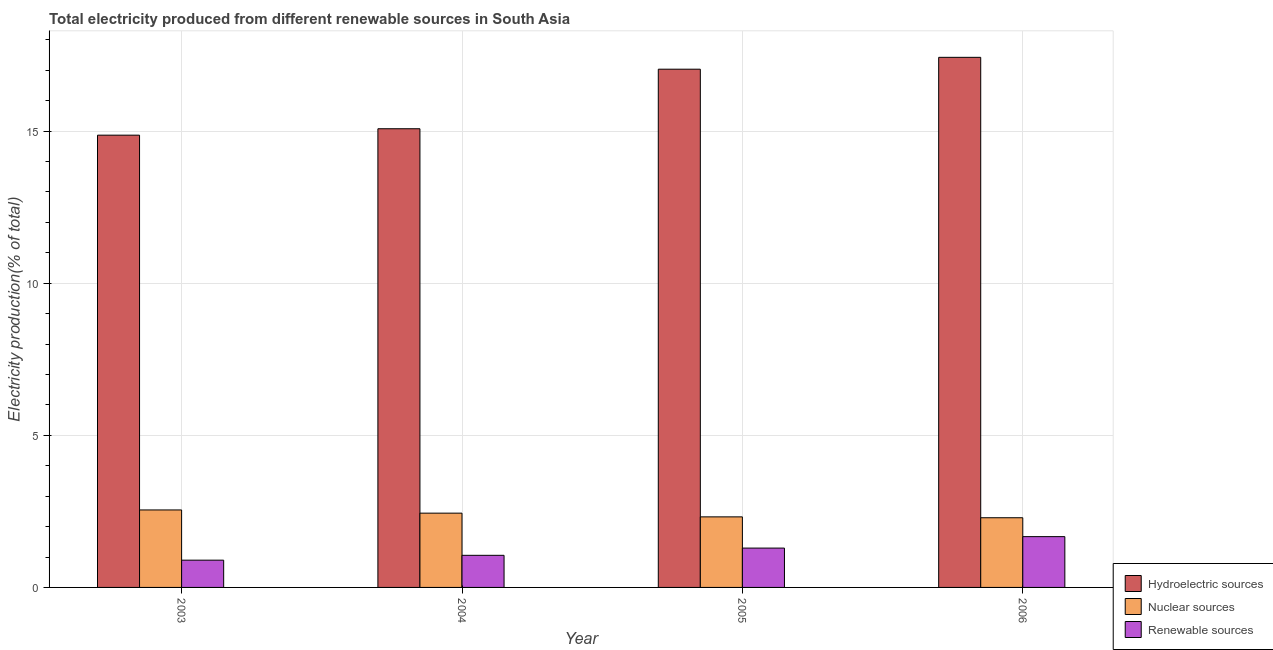How many groups of bars are there?
Keep it short and to the point. 4. Are the number of bars per tick equal to the number of legend labels?
Your answer should be compact. Yes. How many bars are there on the 4th tick from the left?
Your answer should be compact. 3. In how many cases, is the number of bars for a given year not equal to the number of legend labels?
Give a very brief answer. 0. What is the percentage of electricity produced by nuclear sources in 2006?
Your answer should be very brief. 2.29. Across all years, what is the maximum percentage of electricity produced by nuclear sources?
Ensure brevity in your answer.  2.55. Across all years, what is the minimum percentage of electricity produced by nuclear sources?
Offer a very short reply. 2.29. In which year was the percentage of electricity produced by renewable sources maximum?
Offer a terse response. 2006. In which year was the percentage of electricity produced by hydroelectric sources minimum?
Your answer should be compact. 2003. What is the total percentage of electricity produced by nuclear sources in the graph?
Ensure brevity in your answer.  9.6. What is the difference between the percentage of electricity produced by nuclear sources in 2005 and that in 2006?
Offer a very short reply. 0.03. What is the difference between the percentage of electricity produced by hydroelectric sources in 2005 and the percentage of electricity produced by nuclear sources in 2004?
Give a very brief answer. 1.96. What is the average percentage of electricity produced by nuclear sources per year?
Provide a succinct answer. 2.4. In the year 2006, what is the difference between the percentage of electricity produced by hydroelectric sources and percentage of electricity produced by nuclear sources?
Ensure brevity in your answer.  0. What is the ratio of the percentage of electricity produced by renewable sources in 2005 to that in 2006?
Offer a terse response. 0.77. Is the difference between the percentage of electricity produced by hydroelectric sources in 2005 and 2006 greater than the difference between the percentage of electricity produced by renewable sources in 2005 and 2006?
Your answer should be very brief. No. What is the difference between the highest and the second highest percentage of electricity produced by nuclear sources?
Make the answer very short. 0.11. What is the difference between the highest and the lowest percentage of electricity produced by hydroelectric sources?
Offer a terse response. 2.56. In how many years, is the percentage of electricity produced by nuclear sources greater than the average percentage of electricity produced by nuclear sources taken over all years?
Your answer should be compact. 2. Is the sum of the percentage of electricity produced by hydroelectric sources in 2004 and 2006 greater than the maximum percentage of electricity produced by nuclear sources across all years?
Keep it short and to the point. Yes. What does the 2nd bar from the left in 2006 represents?
Offer a very short reply. Nuclear sources. What does the 1st bar from the right in 2004 represents?
Provide a succinct answer. Renewable sources. Is it the case that in every year, the sum of the percentage of electricity produced by hydroelectric sources and percentage of electricity produced by nuclear sources is greater than the percentage of electricity produced by renewable sources?
Provide a short and direct response. Yes. How many bars are there?
Offer a very short reply. 12. What is the difference between two consecutive major ticks on the Y-axis?
Keep it short and to the point. 5. Are the values on the major ticks of Y-axis written in scientific E-notation?
Provide a succinct answer. No. Does the graph contain any zero values?
Your answer should be compact. No. Where does the legend appear in the graph?
Provide a short and direct response. Bottom right. How many legend labels are there?
Provide a short and direct response. 3. How are the legend labels stacked?
Your answer should be very brief. Vertical. What is the title of the graph?
Your response must be concise. Total electricity produced from different renewable sources in South Asia. Does "Taxes on international trade" appear as one of the legend labels in the graph?
Offer a very short reply. No. What is the label or title of the X-axis?
Make the answer very short. Year. What is the Electricity production(% of total) in Hydroelectric sources in 2003?
Make the answer very short. 14.87. What is the Electricity production(% of total) of Nuclear sources in 2003?
Your response must be concise. 2.55. What is the Electricity production(% of total) in Renewable sources in 2003?
Offer a terse response. 0.9. What is the Electricity production(% of total) of Hydroelectric sources in 2004?
Your answer should be compact. 15.08. What is the Electricity production(% of total) of Nuclear sources in 2004?
Make the answer very short. 2.44. What is the Electricity production(% of total) of Renewable sources in 2004?
Give a very brief answer. 1.06. What is the Electricity production(% of total) of Hydroelectric sources in 2005?
Offer a terse response. 17.04. What is the Electricity production(% of total) in Nuclear sources in 2005?
Your answer should be very brief. 2.32. What is the Electricity production(% of total) of Renewable sources in 2005?
Offer a terse response. 1.29. What is the Electricity production(% of total) in Hydroelectric sources in 2006?
Provide a succinct answer. 17.43. What is the Electricity production(% of total) of Nuclear sources in 2006?
Offer a terse response. 2.29. What is the Electricity production(% of total) of Renewable sources in 2006?
Offer a very short reply. 1.67. Across all years, what is the maximum Electricity production(% of total) of Hydroelectric sources?
Your answer should be compact. 17.43. Across all years, what is the maximum Electricity production(% of total) of Nuclear sources?
Ensure brevity in your answer.  2.55. Across all years, what is the maximum Electricity production(% of total) of Renewable sources?
Your response must be concise. 1.67. Across all years, what is the minimum Electricity production(% of total) in Hydroelectric sources?
Your answer should be compact. 14.87. Across all years, what is the minimum Electricity production(% of total) of Nuclear sources?
Offer a very short reply. 2.29. Across all years, what is the minimum Electricity production(% of total) in Renewable sources?
Your response must be concise. 0.9. What is the total Electricity production(% of total) in Hydroelectric sources in the graph?
Offer a very short reply. 64.41. What is the total Electricity production(% of total) of Nuclear sources in the graph?
Make the answer very short. 9.6. What is the total Electricity production(% of total) of Renewable sources in the graph?
Your response must be concise. 4.91. What is the difference between the Electricity production(% of total) of Hydroelectric sources in 2003 and that in 2004?
Your answer should be very brief. -0.21. What is the difference between the Electricity production(% of total) of Nuclear sources in 2003 and that in 2004?
Your response must be concise. 0.11. What is the difference between the Electricity production(% of total) of Renewable sources in 2003 and that in 2004?
Your response must be concise. -0.16. What is the difference between the Electricity production(% of total) of Hydroelectric sources in 2003 and that in 2005?
Your response must be concise. -2.17. What is the difference between the Electricity production(% of total) in Nuclear sources in 2003 and that in 2005?
Provide a short and direct response. 0.23. What is the difference between the Electricity production(% of total) of Renewable sources in 2003 and that in 2005?
Your answer should be very brief. -0.4. What is the difference between the Electricity production(% of total) of Hydroelectric sources in 2003 and that in 2006?
Your answer should be very brief. -2.56. What is the difference between the Electricity production(% of total) of Nuclear sources in 2003 and that in 2006?
Provide a succinct answer. 0.26. What is the difference between the Electricity production(% of total) of Renewable sources in 2003 and that in 2006?
Provide a short and direct response. -0.77. What is the difference between the Electricity production(% of total) in Hydroelectric sources in 2004 and that in 2005?
Offer a terse response. -1.96. What is the difference between the Electricity production(% of total) of Nuclear sources in 2004 and that in 2005?
Keep it short and to the point. 0.12. What is the difference between the Electricity production(% of total) of Renewable sources in 2004 and that in 2005?
Your response must be concise. -0.24. What is the difference between the Electricity production(% of total) in Hydroelectric sources in 2004 and that in 2006?
Provide a short and direct response. -2.35. What is the difference between the Electricity production(% of total) of Nuclear sources in 2004 and that in 2006?
Give a very brief answer. 0.15. What is the difference between the Electricity production(% of total) in Renewable sources in 2004 and that in 2006?
Ensure brevity in your answer.  -0.61. What is the difference between the Electricity production(% of total) in Hydroelectric sources in 2005 and that in 2006?
Ensure brevity in your answer.  -0.39. What is the difference between the Electricity production(% of total) of Nuclear sources in 2005 and that in 2006?
Ensure brevity in your answer.  0.03. What is the difference between the Electricity production(% of total) in Renewable sources in 2005 and that in 2006?
Offer a terse response. -0.38. What is the difference between the Electricity production(% of total) of Hydroelectric sources in 2003 and the Electricity production(% of total) of Nuclear sources in 2004?
Ensure brevity in your answer.  12.42. What is the difference between the Electricity production(% of total) of Hydroelectric sources in 2003 and the Electricity production(% of total) of Renewable sources in 2004?
Ensure brevity in your answer.  13.81. What is the difference between the Electricity production(% of total) of Nuclear sources in 2003 and the Electricity production(% of total) of Renewable sources in 2004?
Your response must be concise. 1.49. What is the difference between the Electricity production(% of total) of Hydroelectric sources in 2003 and the Electricity production(% of total) of Nuclear sources in 2005?
Make the answer very short. 12.55. What is the difference between the Electricity production(% of total) in Hydroelectric sources in 2003 and the Electricity production(% of total) in Renewable sources in 2005?
Offer a very short reply. 13.57. What is the difference between the Electricity production(% of total) of Nuclear sources in 2003 and the Electricity production(% of total) of Renewable sources in 2005?
Keep it short and to the point. 1.25. What is the difference between the Electricity production(% of total) of Hydroelectric sources in 2003 and the Electricity production(% of total) of Nuclear sources in 2006?
Provide a succinct answer. 12.58. What is the difference between the Electricity production(% of total) in Hydroelectric sources in 2003 and the Electricity production(% of total) in Renewable sources in 2006?
Give a very brief answer. 13.2. What is the difference between the Electricity production(% of total) in Nuclear sources in 2003 and the Electricity production(% of total) in Renewable sources in 2006?
Your answer should be very brief. 0.88. What is the difference between the Electricity production(% of total) of Hydroelectric sources in 2004 and the Electricity production(% of total) of Nuclear sources in 2005?
Make the answer very short. 12.76. What is the difference between the Electricity production(% of total) in Hydroelectric sources in 2004 and the Electricity production(% of total) in Renewable sources in 2005?
Offer a very short reply. 13.78. What is the difference between the Electricity production(% of total) in Nuclear sources in 2004 and the Electricity production(% of total) in Renewable sources in 2005?
Your response must be concise. 1.15. What is the difference between the Electricity production(% of total) of Hydroelectric sources in 2004 and the Electricity production(% of total) of Nuclear sources in 2006?
Offer a terse response. 12.79. What is the difference between the Electricity production(% of total) in Hydroelectric sources in 2004 and the Electricity production(% of total) in Renewable sources in 2006?
Make the answer very short. 13.41. What is the difference between the Electricity production(% of total) of Nuclear sources in 2004 and the Electricity production(% of total) of Renewable sources in 2006?
Keep it short and to the point. 0.77. What is the difference between the Electricity production(% of total) in Hydroelectric sources in 2005 and the Electricity production(% of total) in Nuclear sources in 2006?
Offer a terse response. 14.74. What is the difference between the Electricity production(% of total) in Hydroelectric sources in 2005 and the Electricity production(% of total) in Renewable sources in 2006?
Ensure brevity in your answer.  15.37. What is the difference between the Electricity production(% of total) of Nuclear sources in 2005 and the Electricity production(% of total) of Renewable sources in 2006?
Your response must be concise. 0.65. What is the average Electricity production(% of total) of Hydroelectric sources per year?
Ensure brevity in your answer.  16.1. What is the average Electricity production(% of total) in Nuclear sources per year?
Your answer should be very brief. 2.4. What is the average Electricity production(% of total) in Renewable sources per year?
Give a very brief answer. 1.23. In the year 2003, what is the difference between the Electricity production(% of total) in Hydroelectric sources and Electricity production(% of total) in Nuclear sources?
Your answer should be compact. 12.32. In the year 2003, what is the difference between the Electricity production(% of total) in Hydroelectric sources and Electricity production(% of total) in Renewable sources?
Make the answer very short. 13.97. In the year 2003, what is the difference between the Electricity production(% of total) in Nuclear sources and Electricity production(% of total) in Renewable sources?
Keep it short and to the point. 1.65. In the year 2004, what is the difference between the Electricity production(% of total) of Hydroelectric sources and Electricity production(% of total) of Nuclear sources?
Provide a short and direct response. 12.64. In the year 2004, what is the difference between the Electricity production(% of total) of Hydroelectric sources and Electricity production(% of total) of Renewable sources?
Keep it short and to the point. 14.02. In the year 2004, what is the difference between the Electricity production(% of total) in Nuclear sources and Electricity production(% of total) in Renewable sources?
Make the answer very short. 1.39. In the year 2005, what is the difference between the Electricity production(% of total) of Hydroelectric sources and Electricity production(% of total) of Nuclear sources?
Keep it short and to the point. 14.72. In the year 2005, what is the difference between the Electricity production(% of total) of Hydroelectric sources and Electricity production(% of total) of Renewable sources?
Provide a succinct answer. 15.74. In the year 2005, what is the difference between the Electricity production(% of total) of Nuclear sources and Electricity production(% of total) of Renewable sources?
Make the answer very short. 1.03. In the year 2006, what is the difference between the Electricity production(% of total) of Hydroelectric sources and Electricity production(% of total) of Nuclear sources?
Offer a very short reply. 15.13. In the year 2006, what is the difference between the Electricity production(% of total) of Hydroelectric sources and Electricity production(% of total) of Renewable sources?
Give a very brief answer. 15.76. In the year 2006, what is the difference between the Electricity production(% of total) in Nuclear sources and Electricity production(% of total) in Renewable sources?
Offer a very short reply. 0.62. What is the ratio of the Electricity production(% of total) of Hydroelectric sources in 2003 to that in 2004?
Provide a short and direct response. 0.99. What is the ratio of the Electricity production(% of total) of Nuclear sources in 2003 to that in 2004?
Your response must be concise. 1.04. What is the ratio of the Electricity production(% of total) of Renewable sources in 2003 to that in 2004?
Provide a succinct answer. 0.85. What is the ratio of the Electricity production(% of total) of Hydroelectric sources in 2003 to that in 2005?
Provide a succinct answer. 0.87. What is the ratio of the Electricity production(% of total) in Nuclear sources in 2003 to that in 2005?
Keep it short and to the point. 1.1. What is the ratio of the Electricity production(% of total) in Renewable sources in 2003 to that in 2005?
Offer a very short reply. 0.69. What is the ratio of the Electricity production(% of total) of Hydroelectric sources in 2003 to that in 2006?
Provide a short and direct response. 0.85. What is the ratio of the Electricity production(% of total) of Nuclear sources in 2003 to that in 2006?
Provide a short and direct response. 1.11. What is the ratio of the Electricity production(% of total) in Renewable sources in 2003 to that in 2006?
Give a very brief answer. 0.54. What is the ratio of the Electricity production(% of total) of Hydroelectric sources in 2004 to that in 2005?
Keep it short and to the point. 0.89. What is the ratio of the Electricity production(% of total) of Nuclear sources in 2004 to that in 2005?
Keep it short and to the point. 1.05. What is the ratio of the Electricity production(% of total) in Renewable sources in 2004 to that in 2005?
Your response must be concise. 0.82. What is the ratio of the Electricity production(% of total) of Hydroelectric sources in 2004 to that in 2006?
Keep it short and to the point. 0.87. What is the ratio of the Electricity production(% of total) in Nuclear sources in 2004 to that in 2006?
Your answer should be very brief. 1.07. What is the ratio of the Electricity production(% of total) of Renewable sources in 2004 to that in 2006?
Provide a short and direct response. 0.63. What is the ratio of the Electricity production(% of total) of Hydroelectric sources in 2005 to that in 2006?
Offer a terse response. 0.98. What is the ratio of the Electricity production(% of total) of Nuclear sources in 2005 to that in 2006?
Your answer should be compact. 1.01. What is the ratio of the Electricity production(% of total) in Renewable sources in 2005 to that in 2006?
Provide a short and direct response. 0.77. What is the difference between the highest and the second highest Electricity production(% of total) of Hydroelectric sources?
Provide a succinct answer. 0.39. What is the difference between the highest and the second highest Electricity production(% of total) in Nuclear sources?
Offer a terse response. 0.11. What is the difference between the highest and the second highest Electricity production(% of total) in Renewable sources?
Provide a succinct answer. 0.38. What is the difference between the highest and the lowest Electricity production(% of total) in Hydroelectric sources?
Keep it short and to the point. 2.56. What is the difference between the highest and the lowest Electricity production(% of total) in Nuclear sources?
Offer a very short reply. 0.26. What is the difference between the highest and the lowest Electricity production(% of total) of Renewable sources?
Offer a terse response. 0.77. 